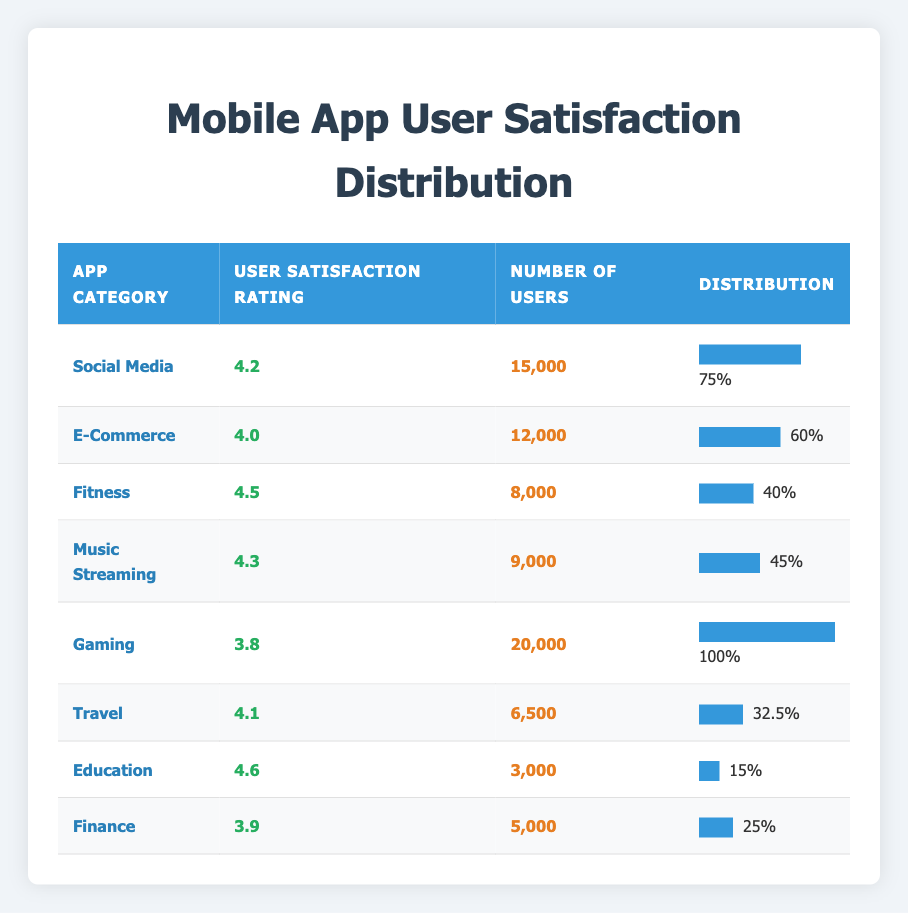What is the user satisfaction rating for the Fitness app category? The table indicates that the user satisfaction rating for the Fitness app category is 4.5.
Answer: 4.5 Which app category has the highest number of users? The highest number of users is listed under the Gaming app category, with 20,000 users.
Answer: Gaming What is the average user satisfaction rating across all app categories? To find the average, add the satisfaction ratings (4.2 + 4.0 + 4.5 + 4.3 + 3.8 + 4.1 + 4.6 + 3.9 = 33.4) and divide by the number of categories (8). Hence, the average is 33.4 / 8 = 4.175.
Answer: 4.175 Is the user satisfaction rating for E-Commerce higher than that for Finance? The table shows that E-Commerce has a satisfaction rating of 4.0, while Finance has a rating of 3.9. Therefore, E-Commerce's rating is indeed higher than Finance's.
Answer: Yes How many more users does the Social Media app category have compared to the Travel app category? The Social Media category has 15,000 users, and the Travel category has 6,500 users. When calculating the difference (15,000 - 6,500), it results in a total of 8,500 more users for Social Media than Travel.
Answer: 8,500 Which app categories have a user satisfaction rating of 4.0 or higher? By reviewing the table, the app categories that meet or exceed a rating of 4.0 are Social Media, E-Commerce, Fitness, Music Streaming, Travel, and Education.
Answer: Social Media, E-Commerce, Fitness, Music Streaming, Travel, Education Is it true that all app categories have user satisfaction ratings above 3.5? Checking each rating, Gaming has a satisfaction rating of 3.8, which is above 3.5. However, Finance is at 3.9 and also above that threshold. Therefore, the statement that all ratings are above 3.5 holds true.
Answer: Yes What is the sum of the user satisfaction ratings for the Education and Music Streaming app categories? The user satisfaction rating for Education is 4.6 and for Music Streaming is 4.3. Summing these ratings gives 4.6 + 4.3 = 8.9.
Answer: 8.9 